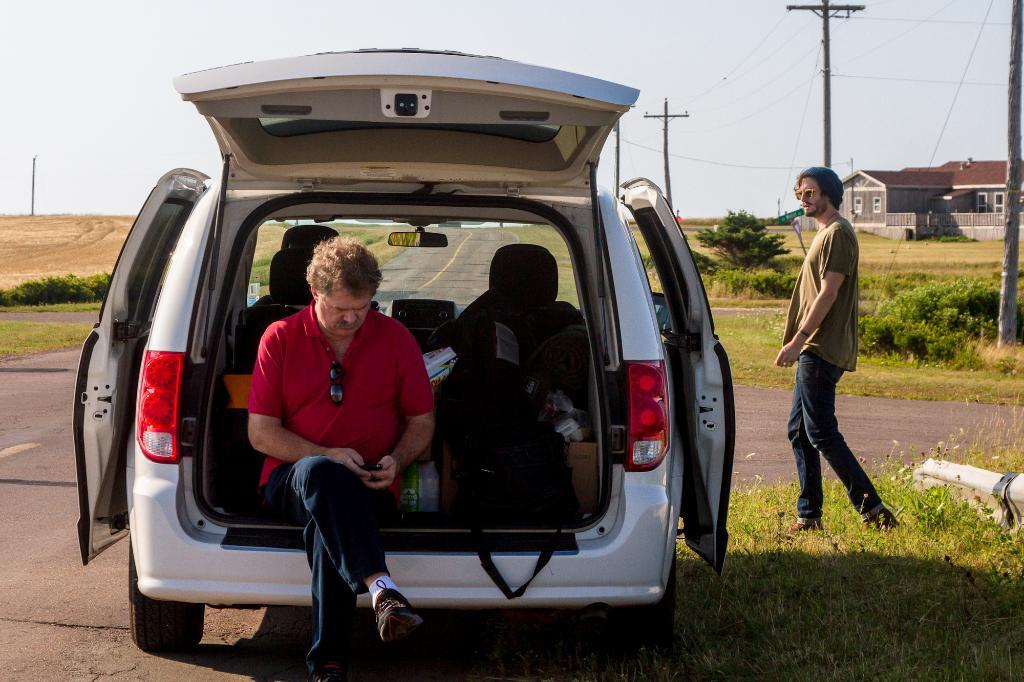What is the man in the car doing? The man is sitting at the back of a car and looking at a mobile. What is the man wearing? The man is wearing a red T-shirt. Where is the car located? The car is parked beside a road. Who else is in the image? There is another man walking towards the car from the right. What type of sponge is the man using to clean the car's wheel in the image? There is no sponge or wheel present in the image; the man is sitting in the car and looking at a mobile. 